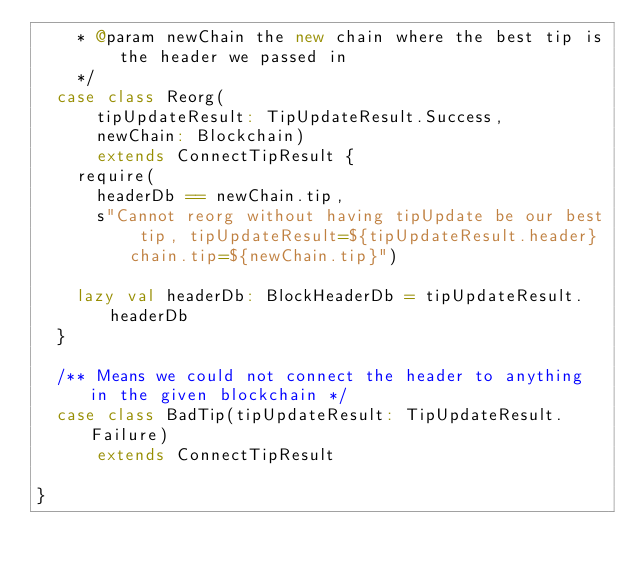<code> <loc_0><loc_0><loc_500><loc_500><_Scala_>    * @param newChain the new chain where the best tip is the header we passed in
    */
  case class Reorg(
      tipUpdateResult: TipUpdateResult.Success,
      newChain: Blockchain)
      extends ConnectTipResult {
    require(
      headerDb == newChain.tip,
      s"Cannot reorg without having tipUpdate be our best tip, tipUpdateResult=${tipUpdateResult.header} chain.tip=${newChain.tip}")

    lazy val headerDb: BlockHeaderDb = tipUpdateResult.headerDb
  }

  /** Means we could not connect the header to anything in the given blockchain */
  case class BadTip(tipUpdateResult: TipUpdateResult.Failure)
      extends ConnectTipResult

}
</code> 